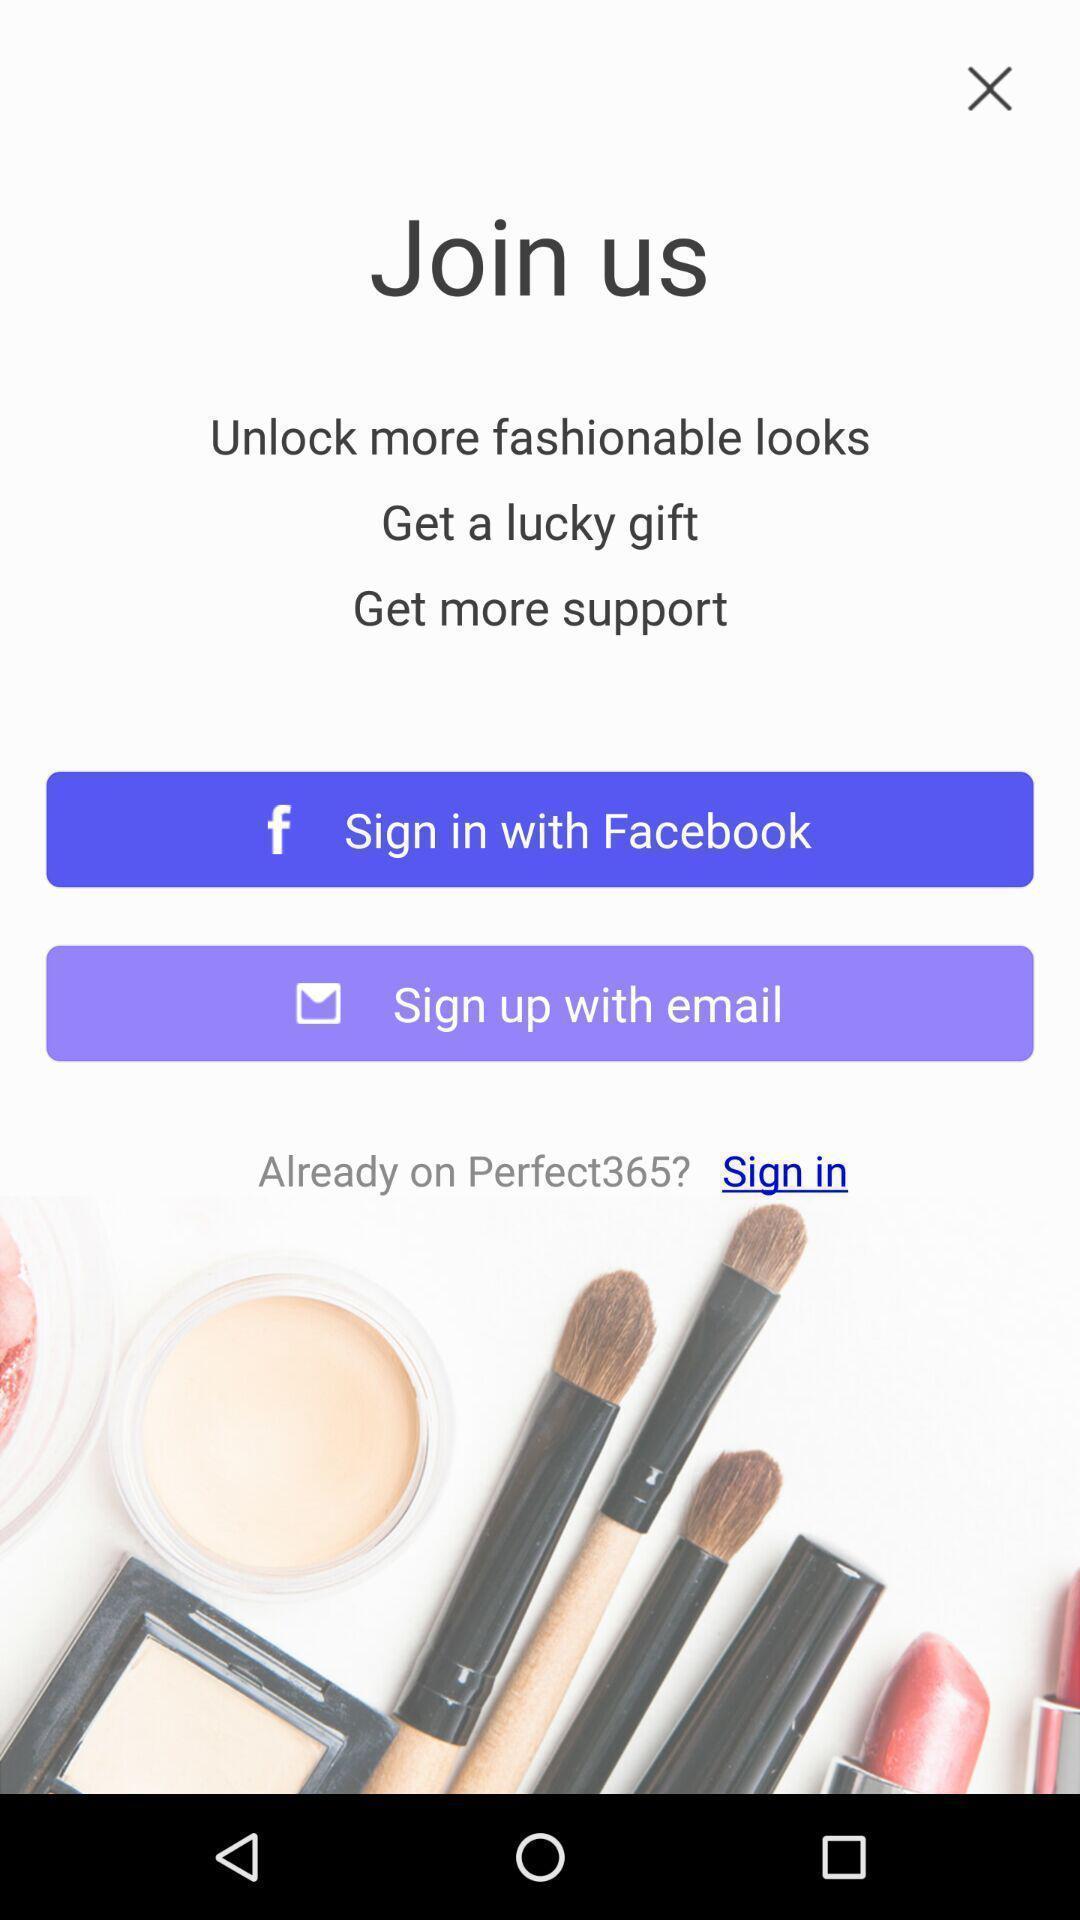Please provide a description for this image. Sign in with different applications displayed of an beauty application. 